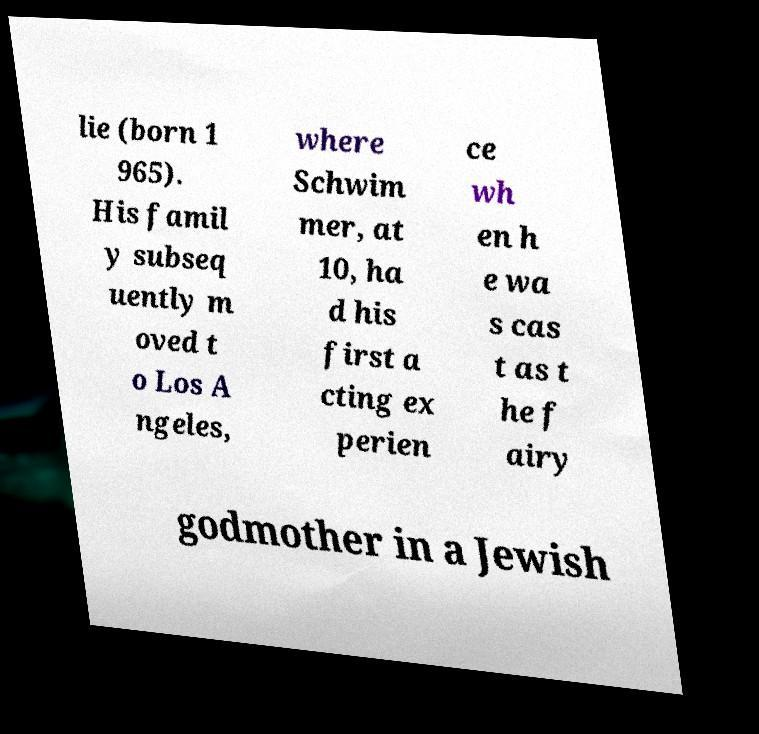What messages or text are displayed in this image? I need them in a readable, typed format. lie (born 1 965). His famil y subseq uently m oved t o Los A ngeles, where Schwim mer, at 10, ha d his first a cting ex perien ce wh en h e wa s cas t as t he f airy godmother in a Jewish 